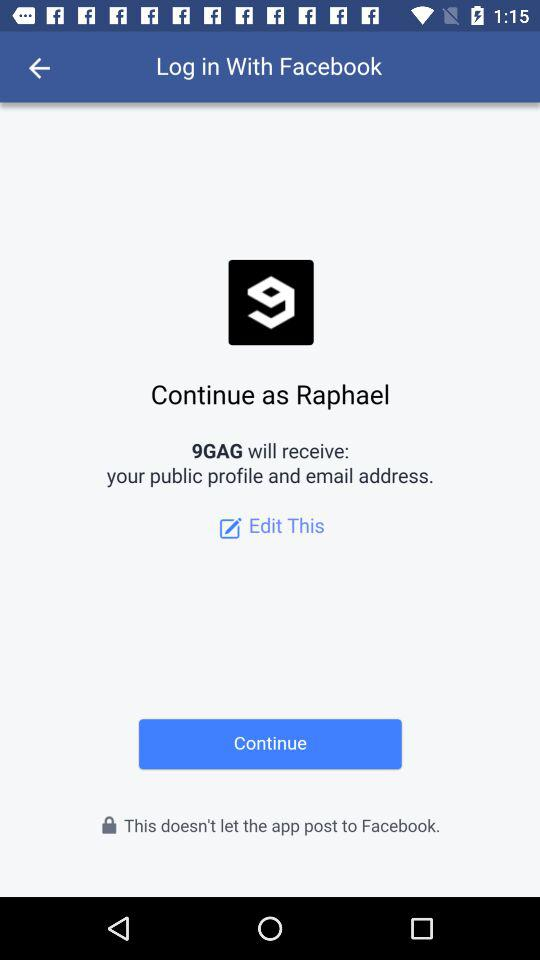What is the user name? The user name is Raphael. 